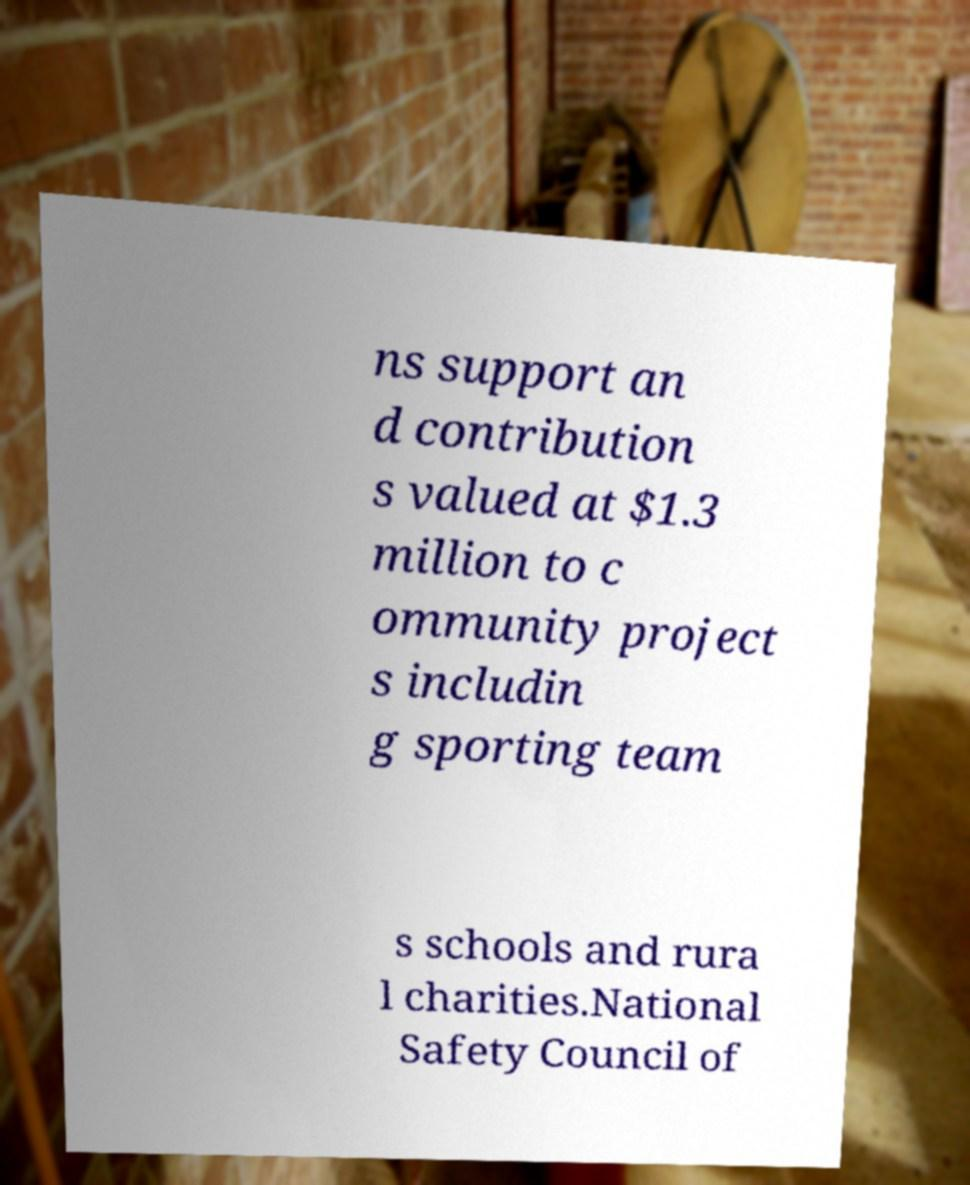What messages or text are displayed in this image? I need them in a readable, typed format. ns support an d contribution s valued at $1.3 million to c ommunity project s includin g sporting team s schools and rura l charities.National Safety Council of 